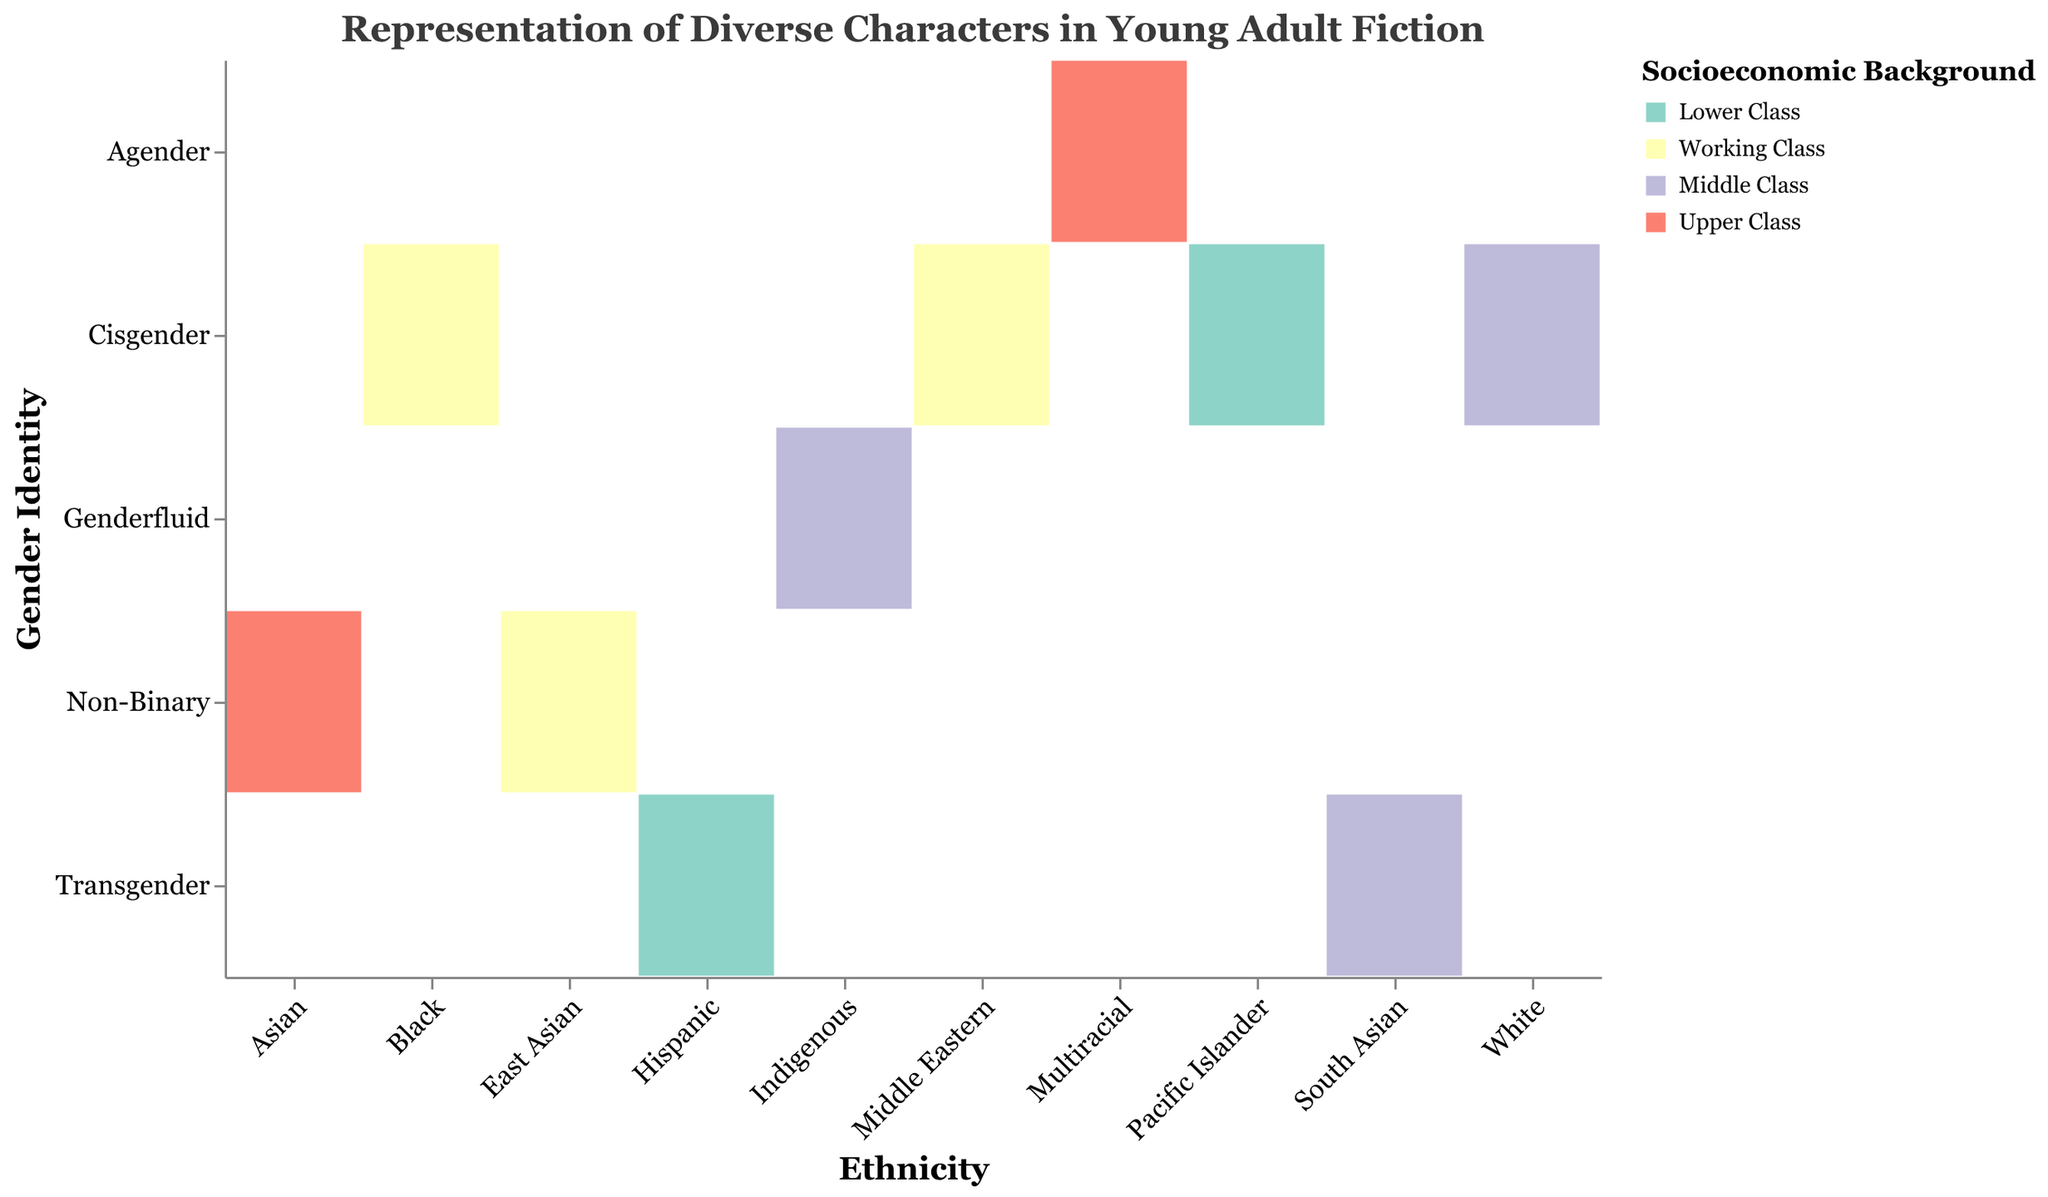1. What is the title of the mosaic plot? The title of a figure is usually the text displayed at the top of the plot. Referring to the given data, the title is "Representation of Diverse Characters in Young Adult Fiction."
Answer: Representation of Diverse Characters in Young Adult Fiction 2. Which ethnicity has the highest number of cisgender characters? By looking at the x-axis labeled for ethnicities and the corresponding sections of the mosaic plot for cisgender characters on the y-axis, identify which ethnicity has the largest section. White has the largest section.
Answer: White 3. How many working-class characters are identified as Middle Eastern? Referring to the color legend, working class sections are yellow. Locate the Middle Eastern section on the x-axis and find the corresponding yellow rectangle in the mosaic plot. According to the data, there are 25 characters.
Answer: 25 4. Compare the number of non-binary characters from East Asian and Asian ethnicities. Which group has more? Identify sections for non-binary gender identity on the y-axis and compare the sizes of corresponding rectangles for East Asian and Asian ethnicities. East Asian has 22, and Asian has 15. Hence, East Asian has more non-binary characters.
Answer: East Asian 5. How many characters are from an upper-class socioeconomic background? Use the provided colors in the legend to identify all sections representing upper class (light red). Sum up the number of characters in these sections. Upper-class characters: Asian (15) and Multiracial (12), adding up to 15 + 12 = 27.
Answer: 27 6. How many non-binary characters are there in total? Sum the total number of non-binary characters from each ethnicity. Referring to the data: Asian (15), East Asian (22), which adds up to 15 + 22 = 37.
Answer: 37 7. Are there more transgender characters in a middle-class or a lower-class background? Compare the sizes of the corresponding rectangles for middle-class and lower-class backgrounds in the transgender section. Middle Class has South Asian (18), Lower Class has Hispanic (20). 20 > 18, so Lower Class has more.
Answer: Lower Class 8. What is the smallest group in terms of character count in the plot? Identify the smallest rectangle in the mosaic plot by comparing their sizes. The Indigenous Genderfluid Middle-Class group has the smallest section with 10 characters.
Answer: Indigenous Genderfluid Middle Class 9. How does the number of cisgender working-class characters compare to the number of non-binary working-class characters? Identify the sizes of rectangles for cisgender working-class (Black 30, Middle Eastern 25 = 55) and non-binary working-class (East Asian 22). Compare: 55 > 22.
Answer: Cisgender working-class characters are more 10. What is the percentage of white cisgender middle-class characters out of the total number of characters? Sum up the total number of characters provided in the data (195). The number of White Cisgender Middle-Class characters is 45. The percentage is calculated by (45 / 195) * 100%.
Answer: 23.08% 